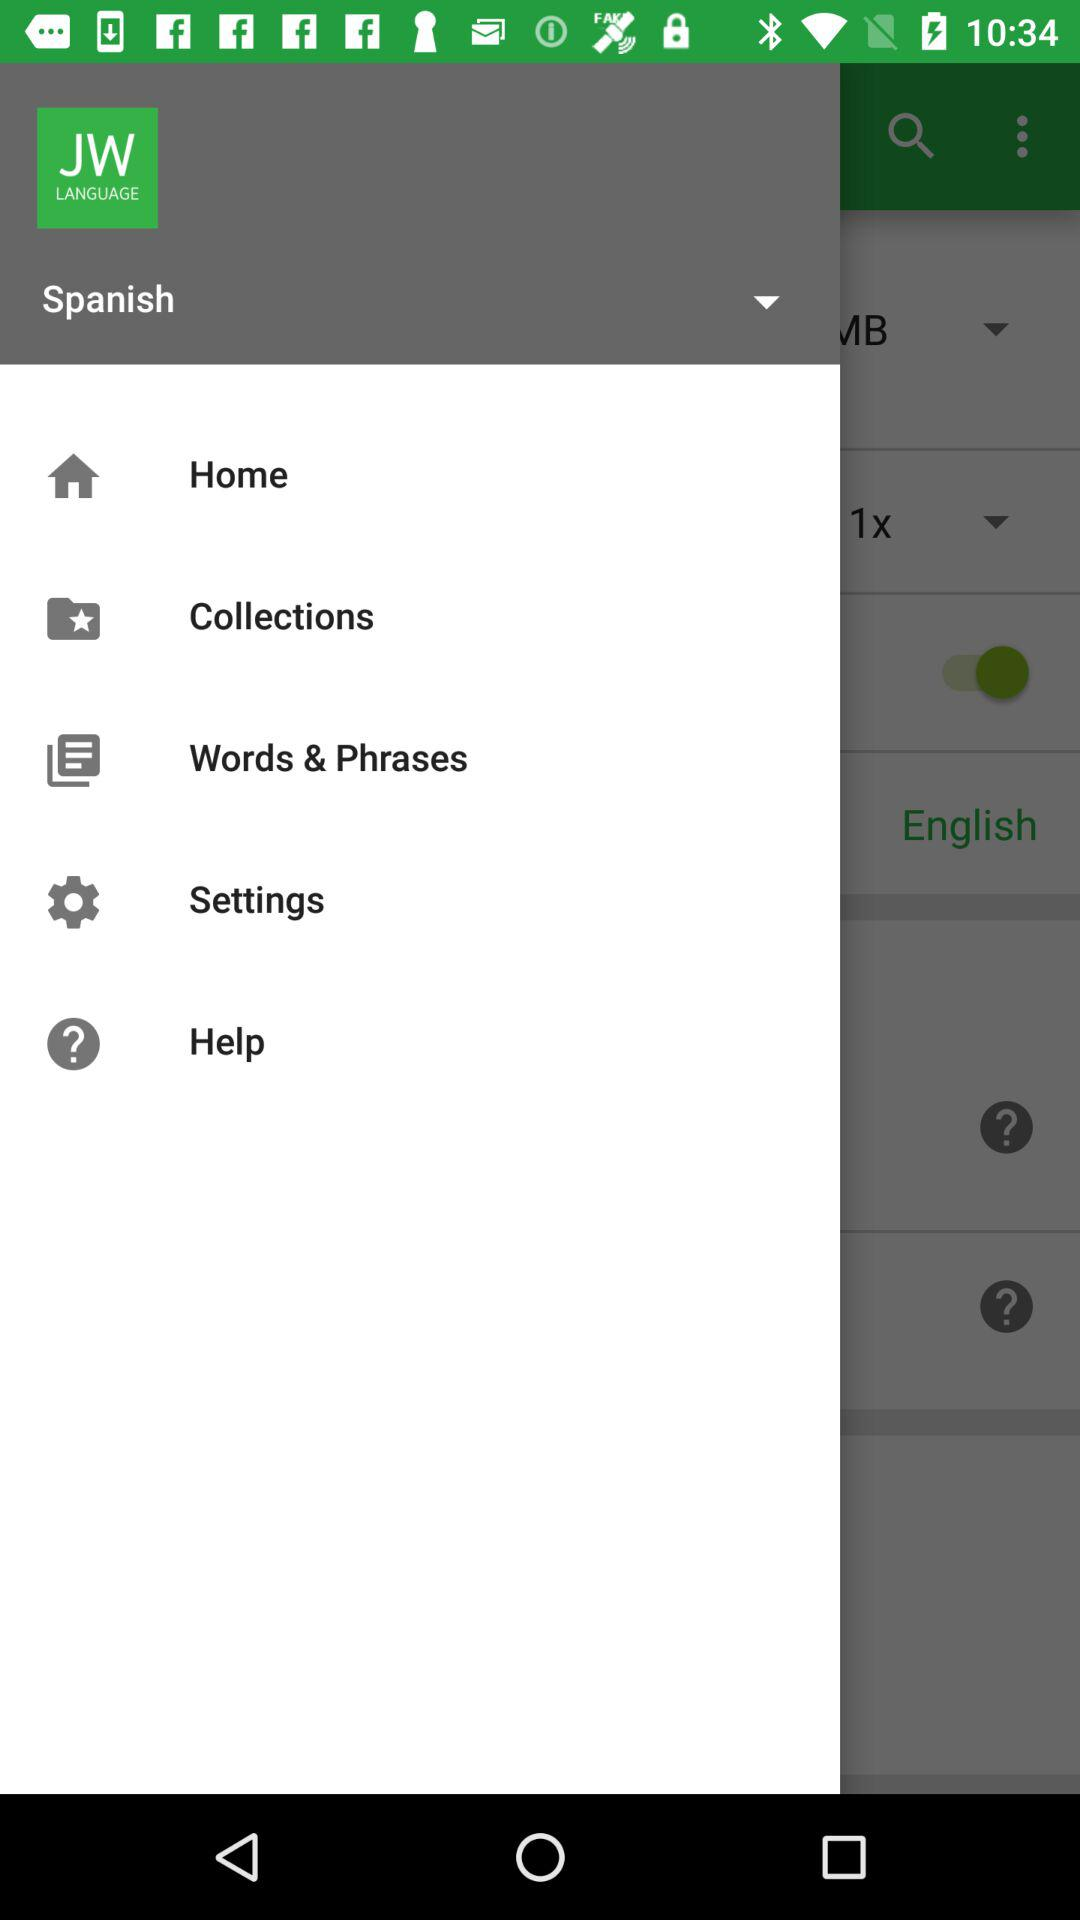What is the name of the application? The name of the application is "JW LANGUAGE". 